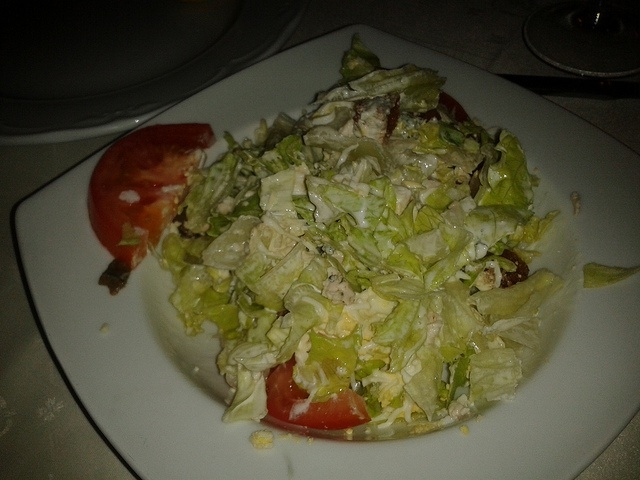Describe the objects in this image and their specific colors. I can see dining table in black, darkgreen, and gray tones and knife in black tones in this image. 